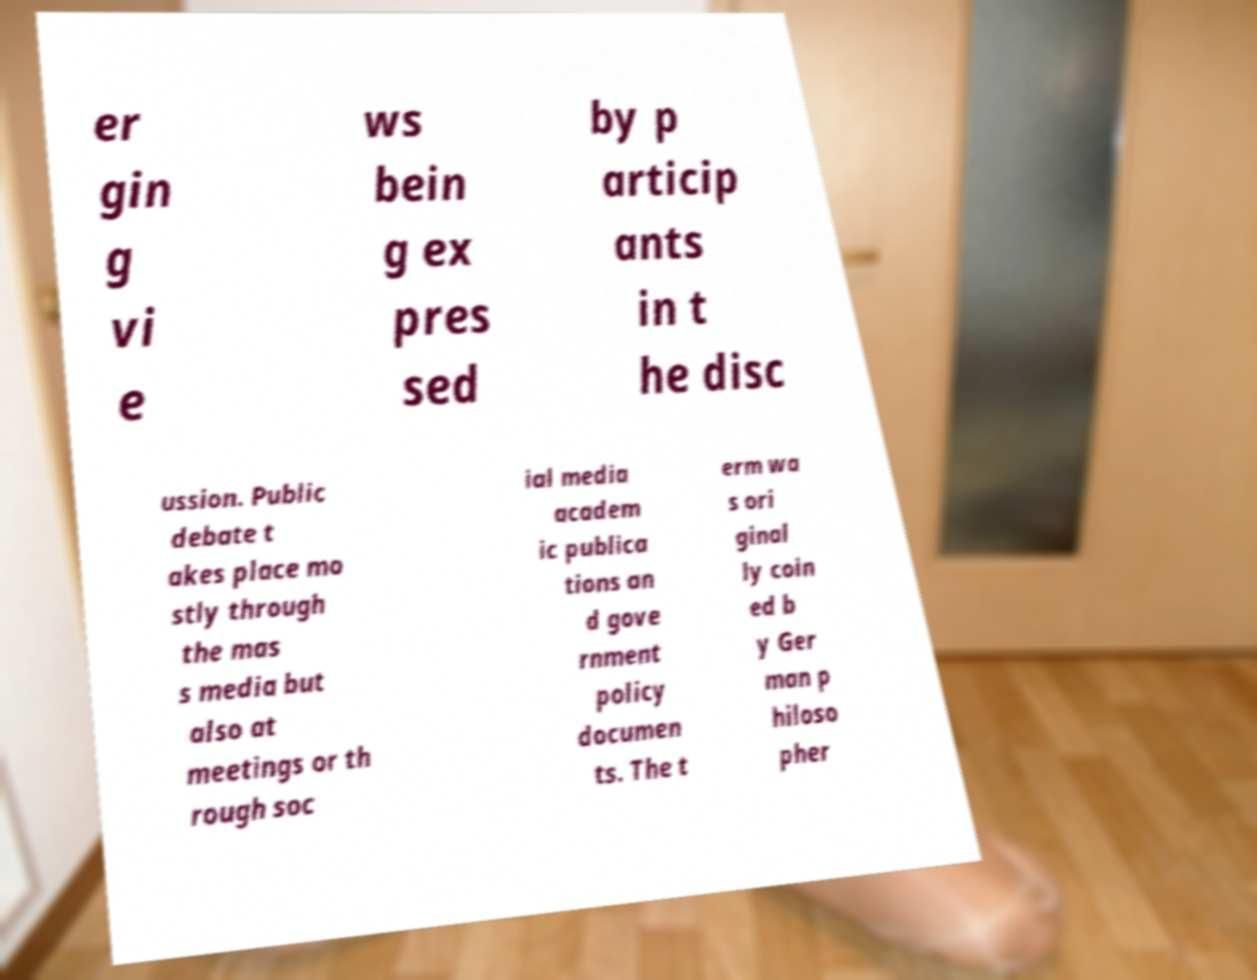Can you read and provide the text displayed in the image?This photo seems to have some interesting text. Can you extract and type it out for me? er gin g vi e ws bein g ex pres sed by p articip ants in t he disc ussion. Public debate t akes place mo stly through the mas s media but also at meetings or th rough soc ial media academ ic publica tions an d gove rnment policy documen ts. The t erm wa s ori ginal ly coin ed b y Ger man p hiloso pher 